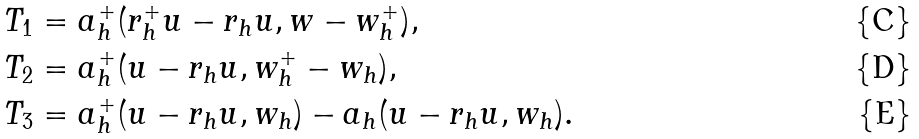<formula> <loc_0><loc_0><loc_500><loc_500>T _ { 1 } & = a _ { h } ^ { + } ( r _ { h } ^ { + } u - r _ { h } u , w - w _ { h } ^ { + } ) , \\ T _ { 2 } & = a _ { h } ^ { + } ( u - r _ { h } u , w _ { h } ^ { + } - w _ { h } ) , \\ T _ { 3 } & = a _ { h } ^ { + } ( u - r _ { h } u , w _ { h } ) - a _ { h } ( u - r _ { h } u , w _ { h } ) .</formula> 